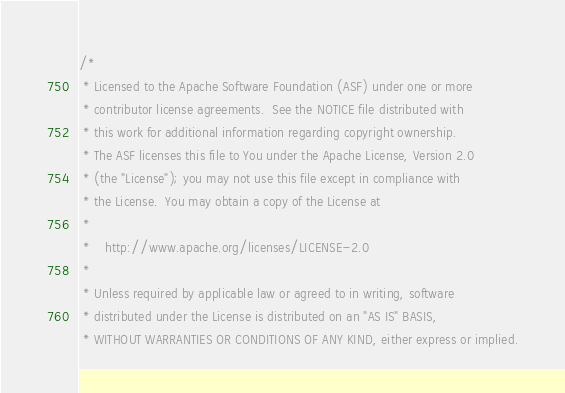<code> <loc_0><loc_0><loc_500><loc_500><_Scala_>/*
 * Licensed to the Apache Software Foundation (ASF) under one or more
 * contributor license agreements.  See the NOTICE file distributed with
 * this work for additional information regarding copyright ownership.
 * The ASF licenses this file to You under the Apache License, Version 2.0
 * (the "License"); you may not use this file except in compliance with
 * the License.  You may obtain a copy of the License at
 *
 *    http://www.apache.org/licenses/LICENSE-2.0
 *
 * Unless required by applicable law or agreed to in writing, software
 * distributed under the License is distributed on an "AS IS" BASIS,
 * WITHOUT WARRANTIES OR CONDITIONS OF ANY KIND, either express or implied.</code> 